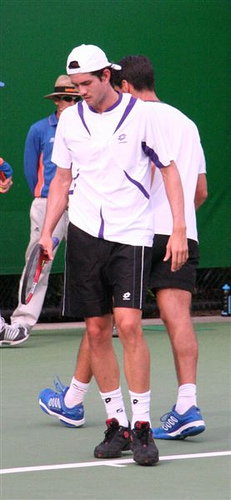<image>What color hat is the man with blue shoes wearing? The man is not wearing a hat. What color hat is the man with blue shoes wearing? It is unknown what color hat is the man with blue shoes wearing. He is not wearing any hat. 